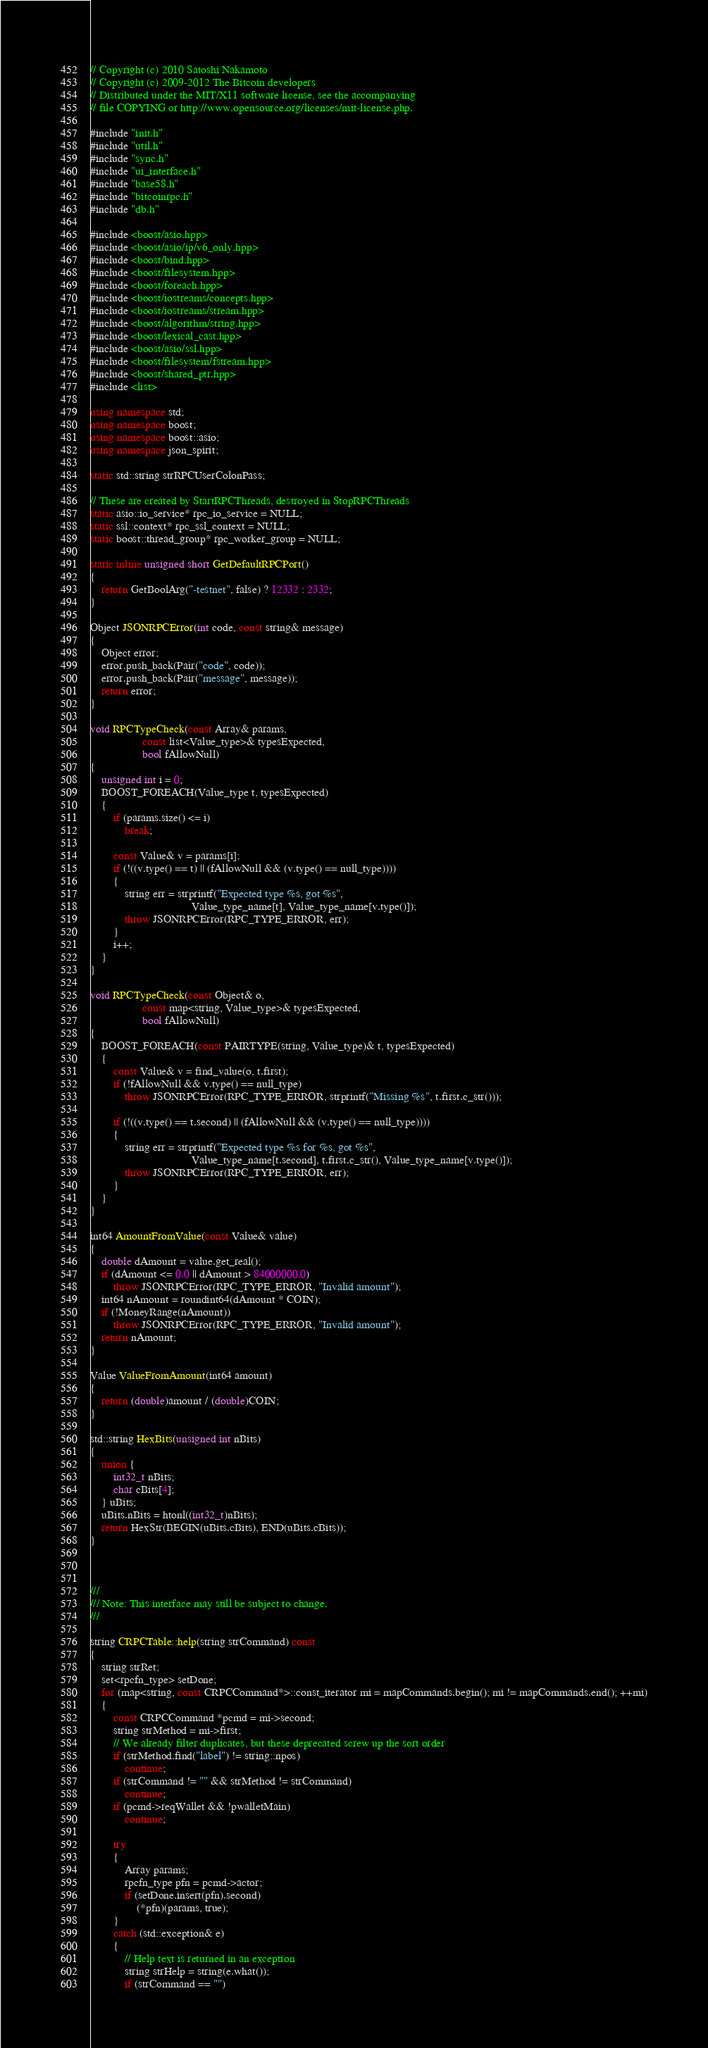Convert code to text. <code><loc_0><loc_0><loc_500><loc_500><_C++_>// Copyright (c) 2010 Satoshi Nakamoto
// Copyright (c) 2009-2012 The Bitcoin developers
// Distributed under the MIT/X11 software license, see the accompanying
// file COPYING or http://www.opensource.org/licenses/mit-license.php.

#include "init.h"
#include "util.h"
#include "sync.h"
#include "ui_interface.h"
#include "base58.h"
#include "bitcoinrpc.h"
#include "db.h"

#include <boost/asio.hpp>
#include <boost/asio/ip/v6_only.hpp>
#include <boost/bind.hpp>
#include <boost/filesystem.hpp>
#include <boost/foreach.hpp>
#include <boost/iostreams/concepts.hpp>
#include <boost/iostreams/stream.hpp>
#include <boost/algorithm/string.hpp>
#include <boost/lexical_cast.hpp>
#include <boost/asio/ssl.hpp>
#include <boost/filesystem/fstream.hpp>
#include <boost/shared_ptr.hpp>
#include <list>

using namespace std;
using namespace boost;
using namespace boost::asio;
using namespace json_spirit;

static std::string strRPCUserColonPass;

// These are created by StartRPCThreads, destroyed in StopRPCThreads
static asio::io_service* rpc_io_service = NULL;
static ssl::context* rpc_ssl_context = NULL;
static boost::thread_group* rpc_worker_group = NULL;

static inline unsigned short GetDefaultRPCPort()
{
    return GetBoolArg("-testnet", false) ? 12332 : 2332;
}

Object JSONRPCError(int code, const string& message)
{
    Object error;
    error.push_back(Pair("code", code));
    error.push_back(Pair("message", message));
    return error;
}

void RPCTypeCheck(const Array& params,
                  const list<Value_type>& typesExpected,
                  bool fAllowNull)
{
    unsigned int i = 0;
    BOOST_FOREACH(Value_type t, typesExpected)
    {
        if (params.size() <= i)
            break;

        const Value& v = params[i];
        if (!((v.type() == t) || (fAllowNull && (v.type() == null_type))))
        {
            string err = strprintf("Expected type %s, got %s",
                                   Value_type_name[t], Value_type_name[v.type()]);
            throw JSONRPCError(RPC_TYPE_ERROR, err);
        }
        i++;
    }
}

void RPCTypeCheck(const Object& o,
                  const map<string, Value_type>& typesExpected,
                  bool fAllowNull)
{
    BOOST_FOREACH(const PAIRTYPE(string, Value_type)& t, typesExpected)
    {
        const Value& v = find_value(o, t.first);
        if (!fAllowNull && v.type() == null_type)
            throw JSONRPCError(RPC_TYPE_ERROR, strprintf("Missing %s", t.first.c_str()));

        if (!((v.type() == t.second) || (fAllowNull && (v.type() == null_type))))
        {
            string err = strprintf("Expected type %s for %s, got %s",
                                   Value_type_name[t.second], t.first.c_str(), Value_type_name[v.type()]);
            throw JSONRPCError(RPC_TYPE_ERROR, err);
        }
    }
}

int64 AmountFromValue(const Value& value)
{
    double dAmount = value.get_real();
    if (dAmount <= 0.0 || dAmount > 84000000.0)
        throw JSONRPCError(RPC_TYPE_ERROR, "Invalid amount");
    int64 nAmount = roundint64(dAmount * COIN);
    if (!MoneyRange(nAmount))
        throw JSONRPCError(RPC_TYPE_ERROR, "Invalid amount");
    return nAmount;
}

Value ValueFromAmount(int64 amount)
{
    return (double)amount / (double)COIN;
}

std::string HexBits(unsigned int nBits)
{
    union {
        int32_t nBits;
        char cBits[4];
    } uBits;
    uBits.nBits = htonl((int32_t)nBits);
    return HexStr(BEGIN(uBits.cBits), END(uBits.cBits));
}



///
/// Note: This interface may still be subject to change.
///

string CRPCTable::help(string strCommand) const
{
    string strRet;
    set<rpcfn_type> setDone;
    for (map<string, const CRPCCommand*>::const_iterator mi = mapCommands.begin(); mi != mapCommands.end(); ++mi)
    {
        const CRPCCommand *pcmd = mi->second;
        string strMethod = mi->first;
        // We already filter duplicates, but these deprecated screw up the sort order
        if (strMethod.find("label") != string::npos)
            continue;
        if (strCommand != "" && strMethod != strCommand)
            continue;
        if (pcmd->reqWallet && !pwalletMain)
            continue;

        try
        {
            Array params;
            rpcfn_type pfn = pcmd->actor;
            if (setDone.insert(pfn).second)
                (*pfn)(params, true);
        }
        catch (std::exception& e)
        {
            // Help text is returned in an exception
            string strHelp = string(e.what());
            if (strCommand == "")</code> 